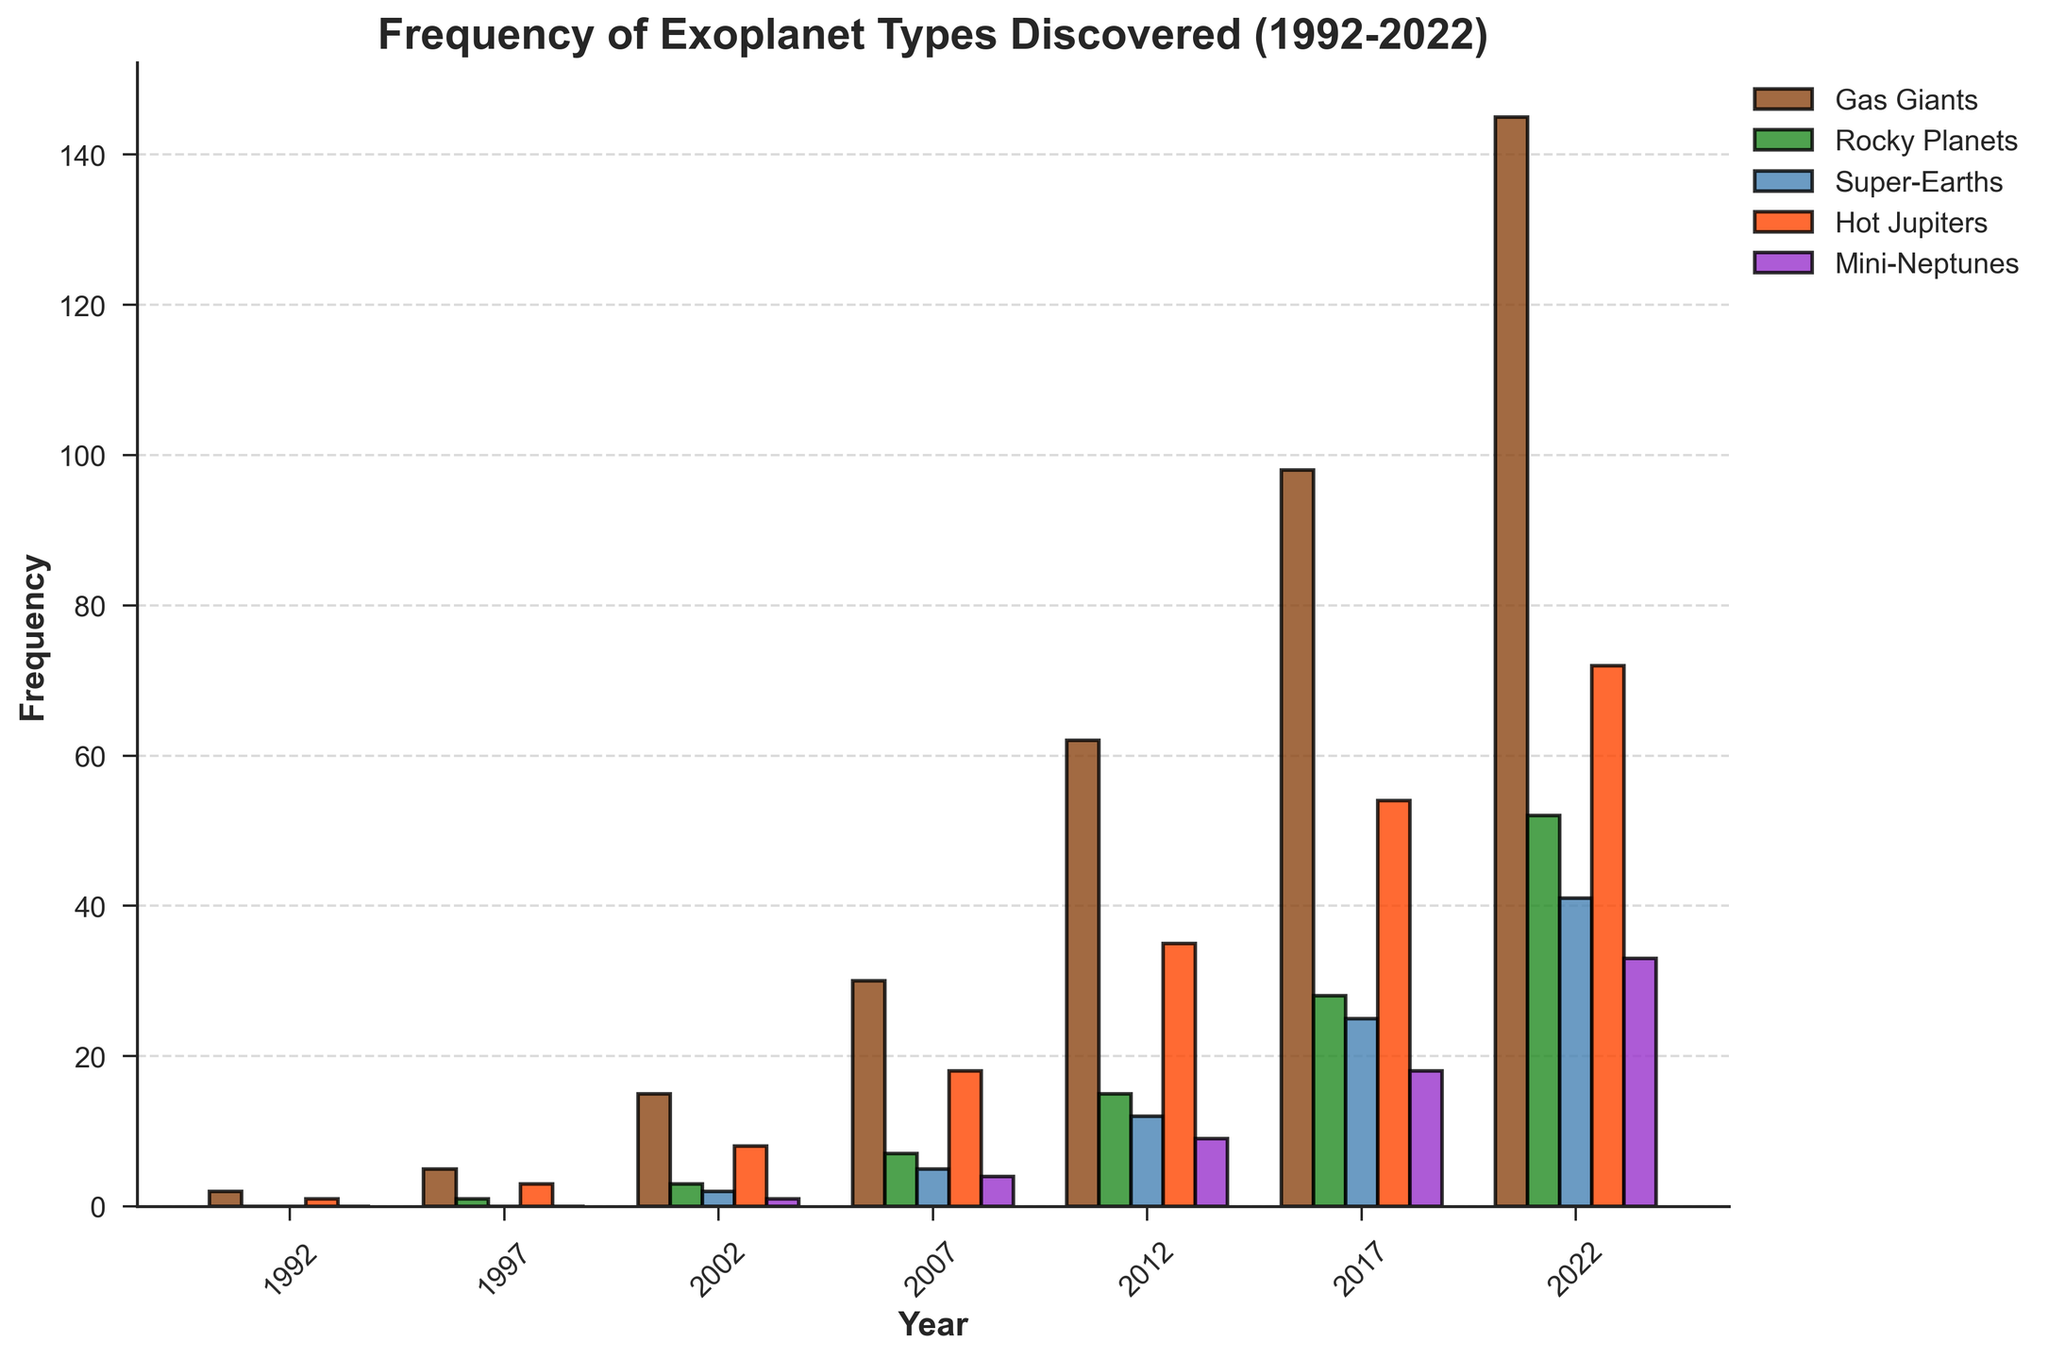What's the total number of Gas Giants discovered up to 2022? Add the frequencies of Gas Giants for each year: 2 (1992) + 5 (1997) + 15 (2002) + 30 (2007) + 62 (2012) + 98 (2017) + 145 (2022).
Answer: 357 Which year had the highest discoveries of Mini-Neptunes? Observe the height of the bars for Mini-Neptunes and identify the year with the tallest bar. The tallest bar is in 2022.
Answer: 2022 Are there more Rocky Planets or Super-Earths discovered in 2017? Compare the bar heights for Rocky Planets and Super-Earths in 2017. Rocky Planets in 2017 is 28, while Super-Earths is 25.
Answer: Rocky Planets In which year did Hot Jupiters exceed 50 discoveries? Look at the Hot Jupiters bars across years and find the first year where the value is greater than 50. In 2017, Hot Jupiters exceed 50.
Answer: 2017 What is the average number of Gas Giants discovered between 1992 and 2022? Sum the frequencies of Gas Giants for the years given, then divide by the number of years: (2 + 5 + 15 + 30 + 62 + 98 + 145)/7. The sum is 357, and the average is 357/7.
Answer: 51 Which planet type shows a steady increase in discoveries from 1992 to 2022? Compare the trend lines of all planet types over the years. All planet types increase, but Gas Giants show the most consistent growth from 2 in 1992 to 145 in 2022.
Answer: Gas Giants By how much did the discoveries of Super-Earths increase from 2002 to 2022? Check the values for Super-Earths in 2002 and 2022 and find the difference: 41 (2022) - 2 (2002).
Answer: 39 What was the total number of exoplanets discovered in 2012 across all types? Sum the values of all planet types for the year 2012: 62 (Gas Giants) + 15 (Rocky Planets) + 12 (Super-Earths) + 35 (Hot Jupiters) + 9 (Mini-Neptunes).
Answer: 133 Which exoplanet type has the highest frequency in 2007? Compare the bar heights for each exoplanet type in 2007. Hot Jupiters at 18 is the highest.
Answer: Hot Jupiters How many more Hot Jupiters were discovered in 2017 compared to 2007? Subtract the number of Hot Jupiters in 2007 from that in 2017: 54 (2017) - 18 (2007).
Answer: 36 